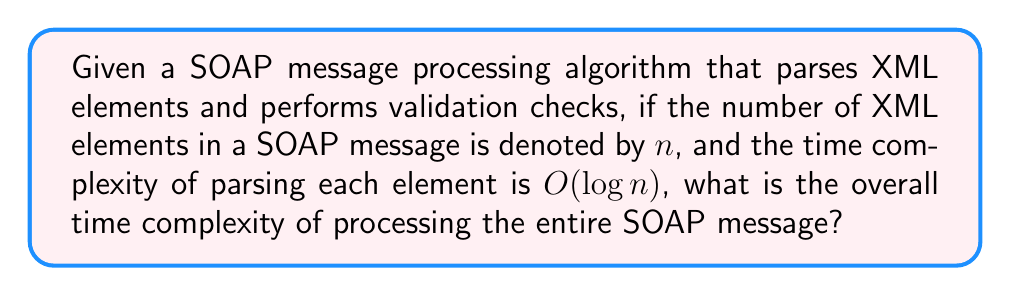Solve this math problem. Let's approach this step-by-step:

1) First, we need to understand that the algorithm processes each XML element in the SOAP message.

2) The number of XML elements is given as $n$.

3) For each element, the parsing time complexity is $O(\log n)$.

4) Since we need to process all $n$ elements, and for each element, we perform an operation with $O(\log n)$ complexity, we need to multiply these:

   $$n \cdot O(\log n)$$

5) In Big O notation, this multiplication results in:

   $$O(n \log n)$$

6) This is because we're performing an $O(\log n)$ operation $n$ times.

7) It's important to note that this is worse than linear time $O(n)$, but better than quadratic time $O(n^2)$.

8) In the context of web applications, this means that as the size of SOAP messages increases, the processing time will grow slightly faster than linear, which could become a bottleneck for very large messages or high traffic scenarios.
Answer: $O(n \log n)$ 